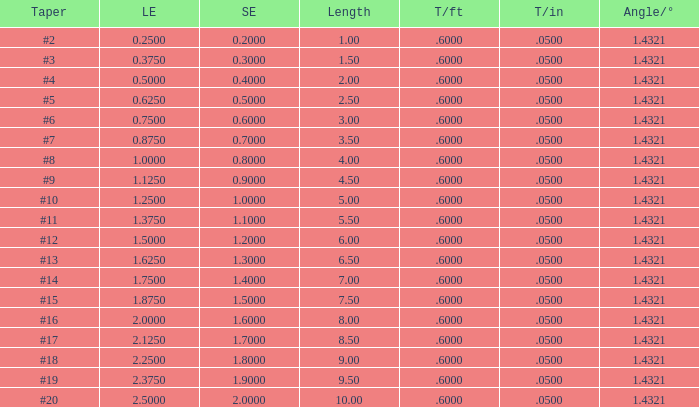Which Taper/ft that has a Large end smaller than 0.5, and a Taper of #2? 0.6. 